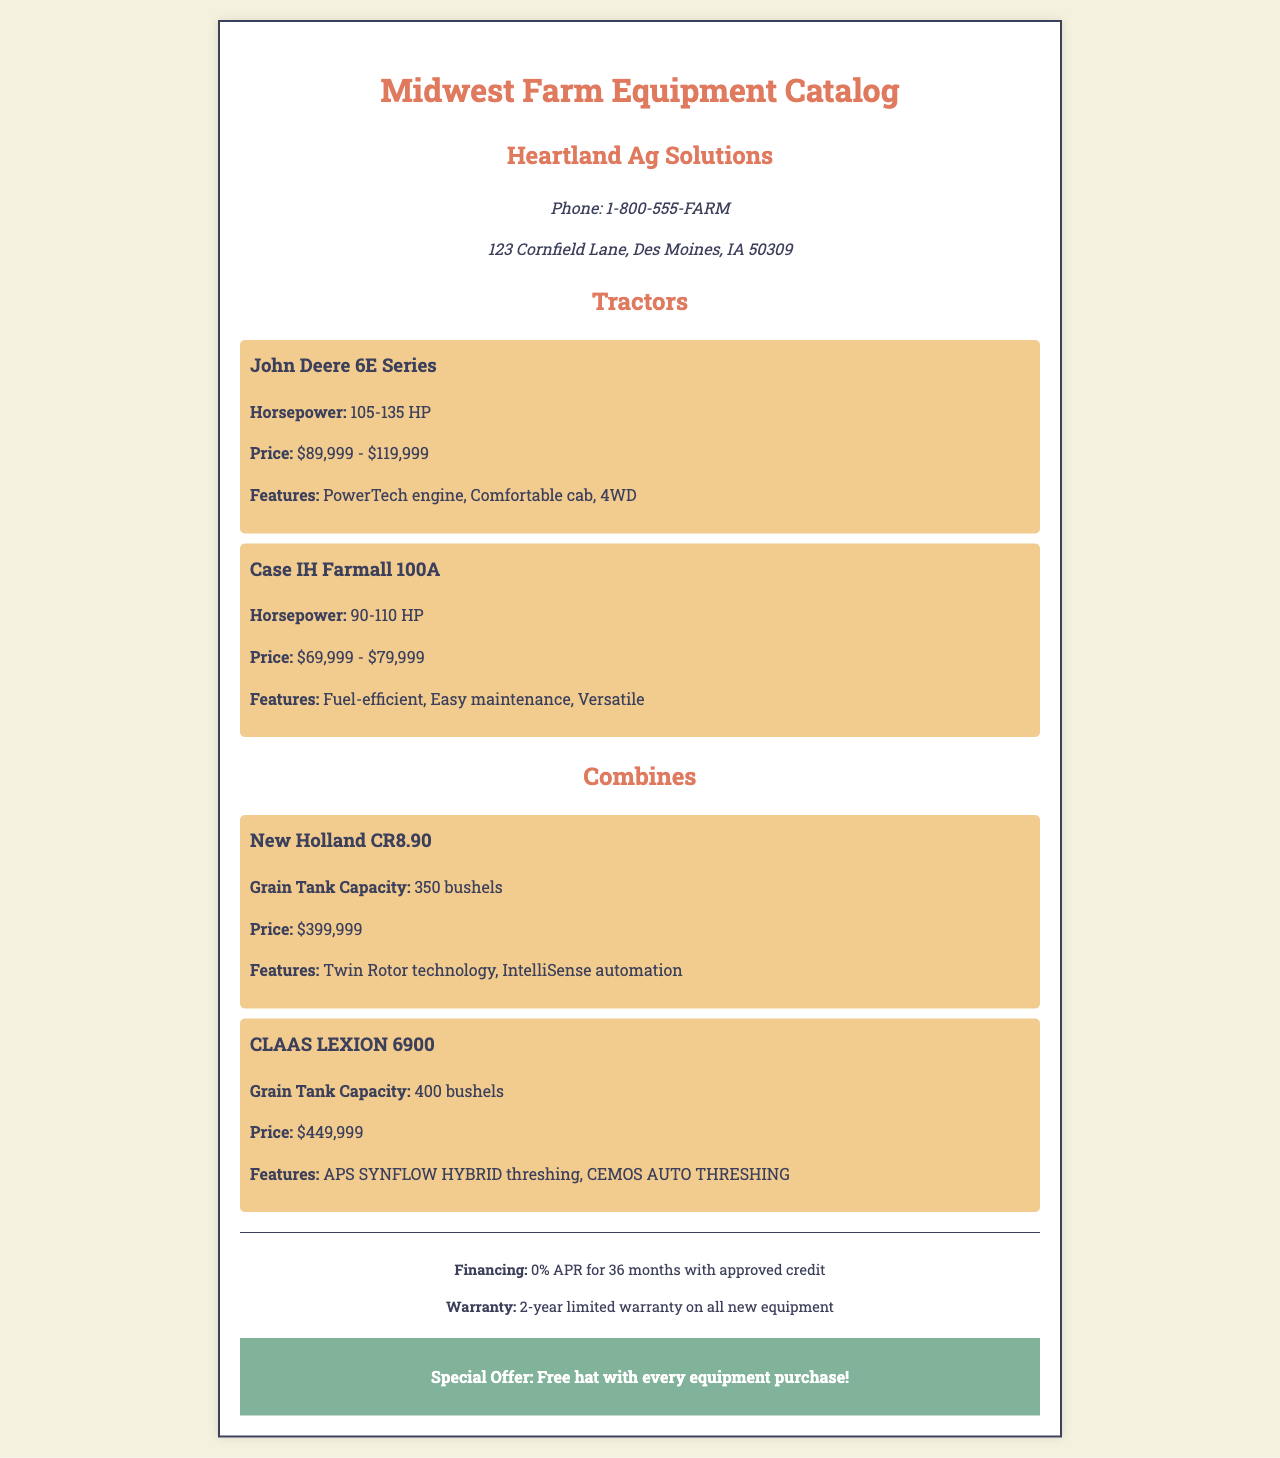What is the name of the catalog? The name of the catalog is displayed prominently at the top of the document.
Answer: Midwest Farm Equipment Catalog Who is the company behind the catalog? The company name is mentioned below the catalog title.
Answer: Heartland Ag Solutions What is the horsepower range for the John Deere 6E Series? The horsepower range is specified in the equipment section for tractors.
Answer: 105-135 HP What is the price range for the Case IH Farmall 100A? The price range is provided in the description of the equipment.
Answer: $69,999 - $79,999 What is the grain tank capacity of the CLAAS LEXION 6900? The grain tank capacity is listed in the combines section of the document.
Answer: 400 bushels What financing option is available for equipment purchases? The financing option is stated in the footer section of the document.
Answer: 0% APR for 36 months What special offer is mentioned in the document? The special offer is highlighted in a separate section of the document.
Answer: Free hat with every equipment purchase Which combine has the Twin Rotor technology? The technology feature is noted in the description of the combine.
Answer: New Holland CR8.90 What type of warranty is provided for all new equipment? The warranty information is specified in the footer.
Answer: 2-year limited warranty 